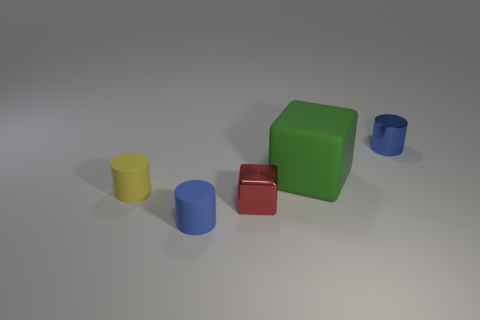What shapes are visible in the image besides the cylinders? In addition to the two cylinders, there's a green cube and a smaller red cube, creating a simple yet visually interesting composition of basic geometric shapes. 